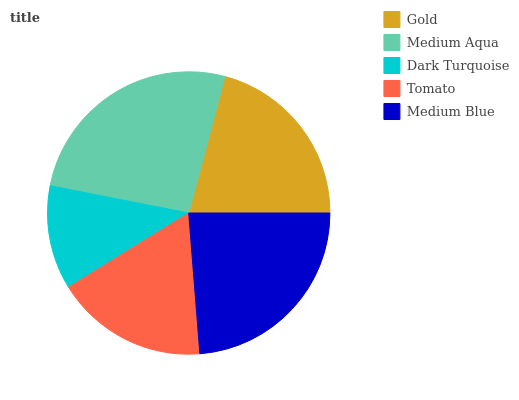Is Dark Turquoise the minimum?
Answer yes or no. Yes. Is Medium Aqua the maximum?
Answer yes or no. Yes. Is Medium Aqua the minimum?
Answer yes or no. No. Is Dark Turquoise the maximum?
Answer yes or no. No. Is Medium Aqua greater than Dark Turquoise?
Answer yes or no. Yes. Is Dark Turquoise less than Medium Aqua?
Answer yes or no. Yes. Is Dark Turquoise greater than Medium Aqua?
Answer yes or no. No. Is Medium Aqua less than Dark Turquoise?
Answer yes or no. No. Is Gold the high median?
Answer yes or no. Yes. Is Gold the low median?
Answer yes or no. Yes. Is Dark Turquoise the high median?
Answer yes or no. No. Is Medium Blue the low median?
Answer yes or no. No. 